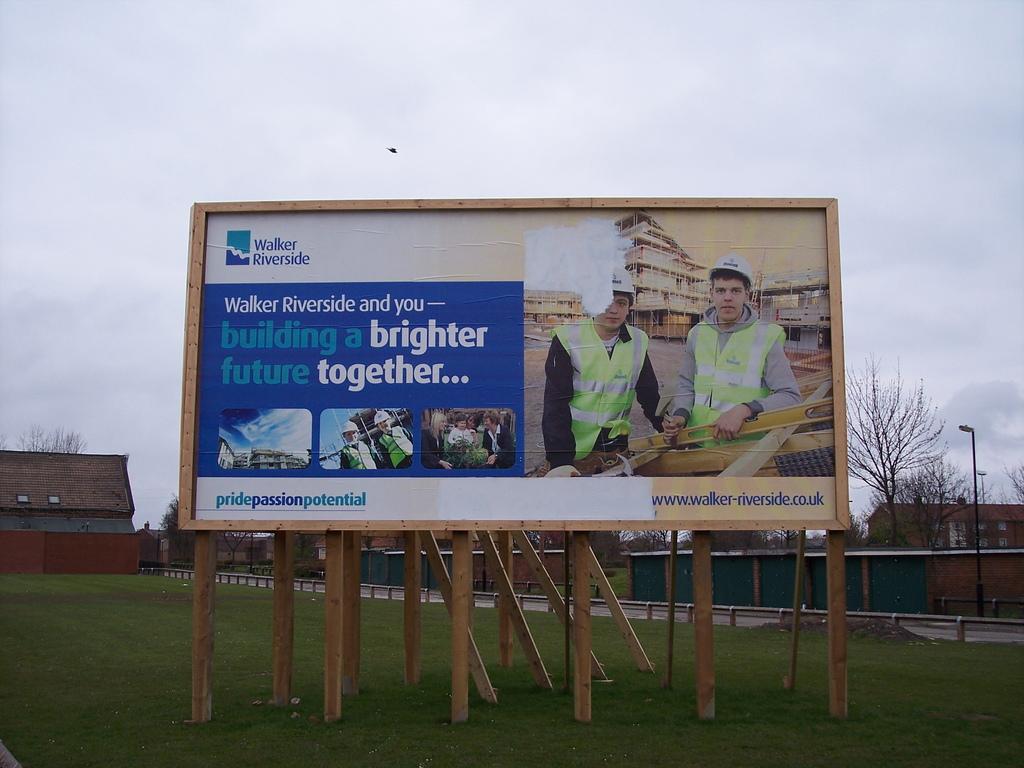What is this billboard advertising building?
Your response must be concise. Walker riverside. Who is the advert for?
Your answer should be compact. Walker riverside. 